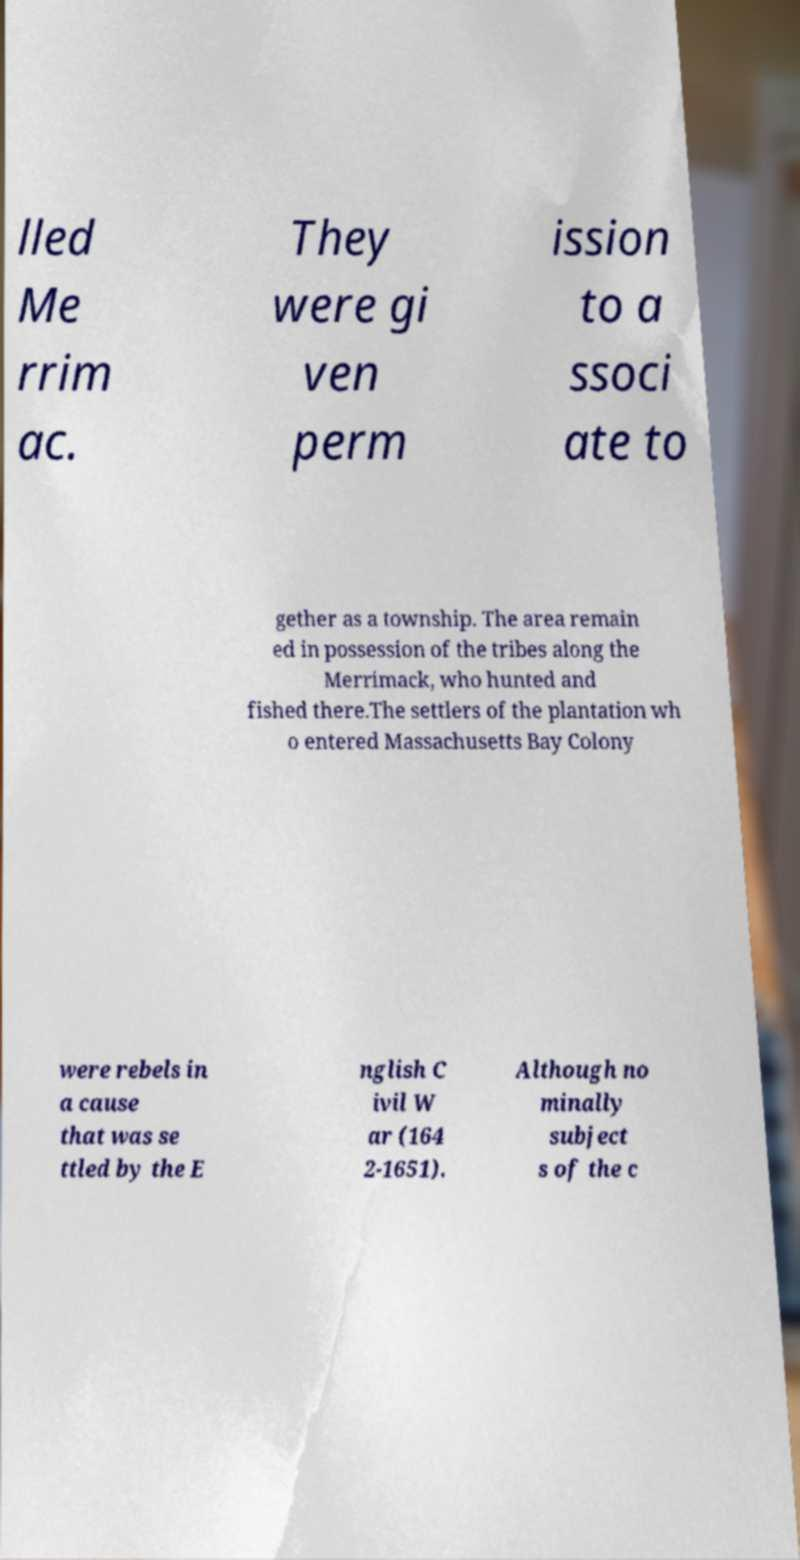Please identify and transcribe the text found in this image. lled Me rrim ac. They were gi ven perm ission to a ssoci ate to gether as a township. The area remain ed in possession of the tribes along the Merrimack, who hunted and fished there.The settlers of the plantation wh o entered Massachusetts Bay Colony were rebels in a cause that was se ttled by the E nglish C ivil W ar (164 2-1651). Although no minally subject s of the c 